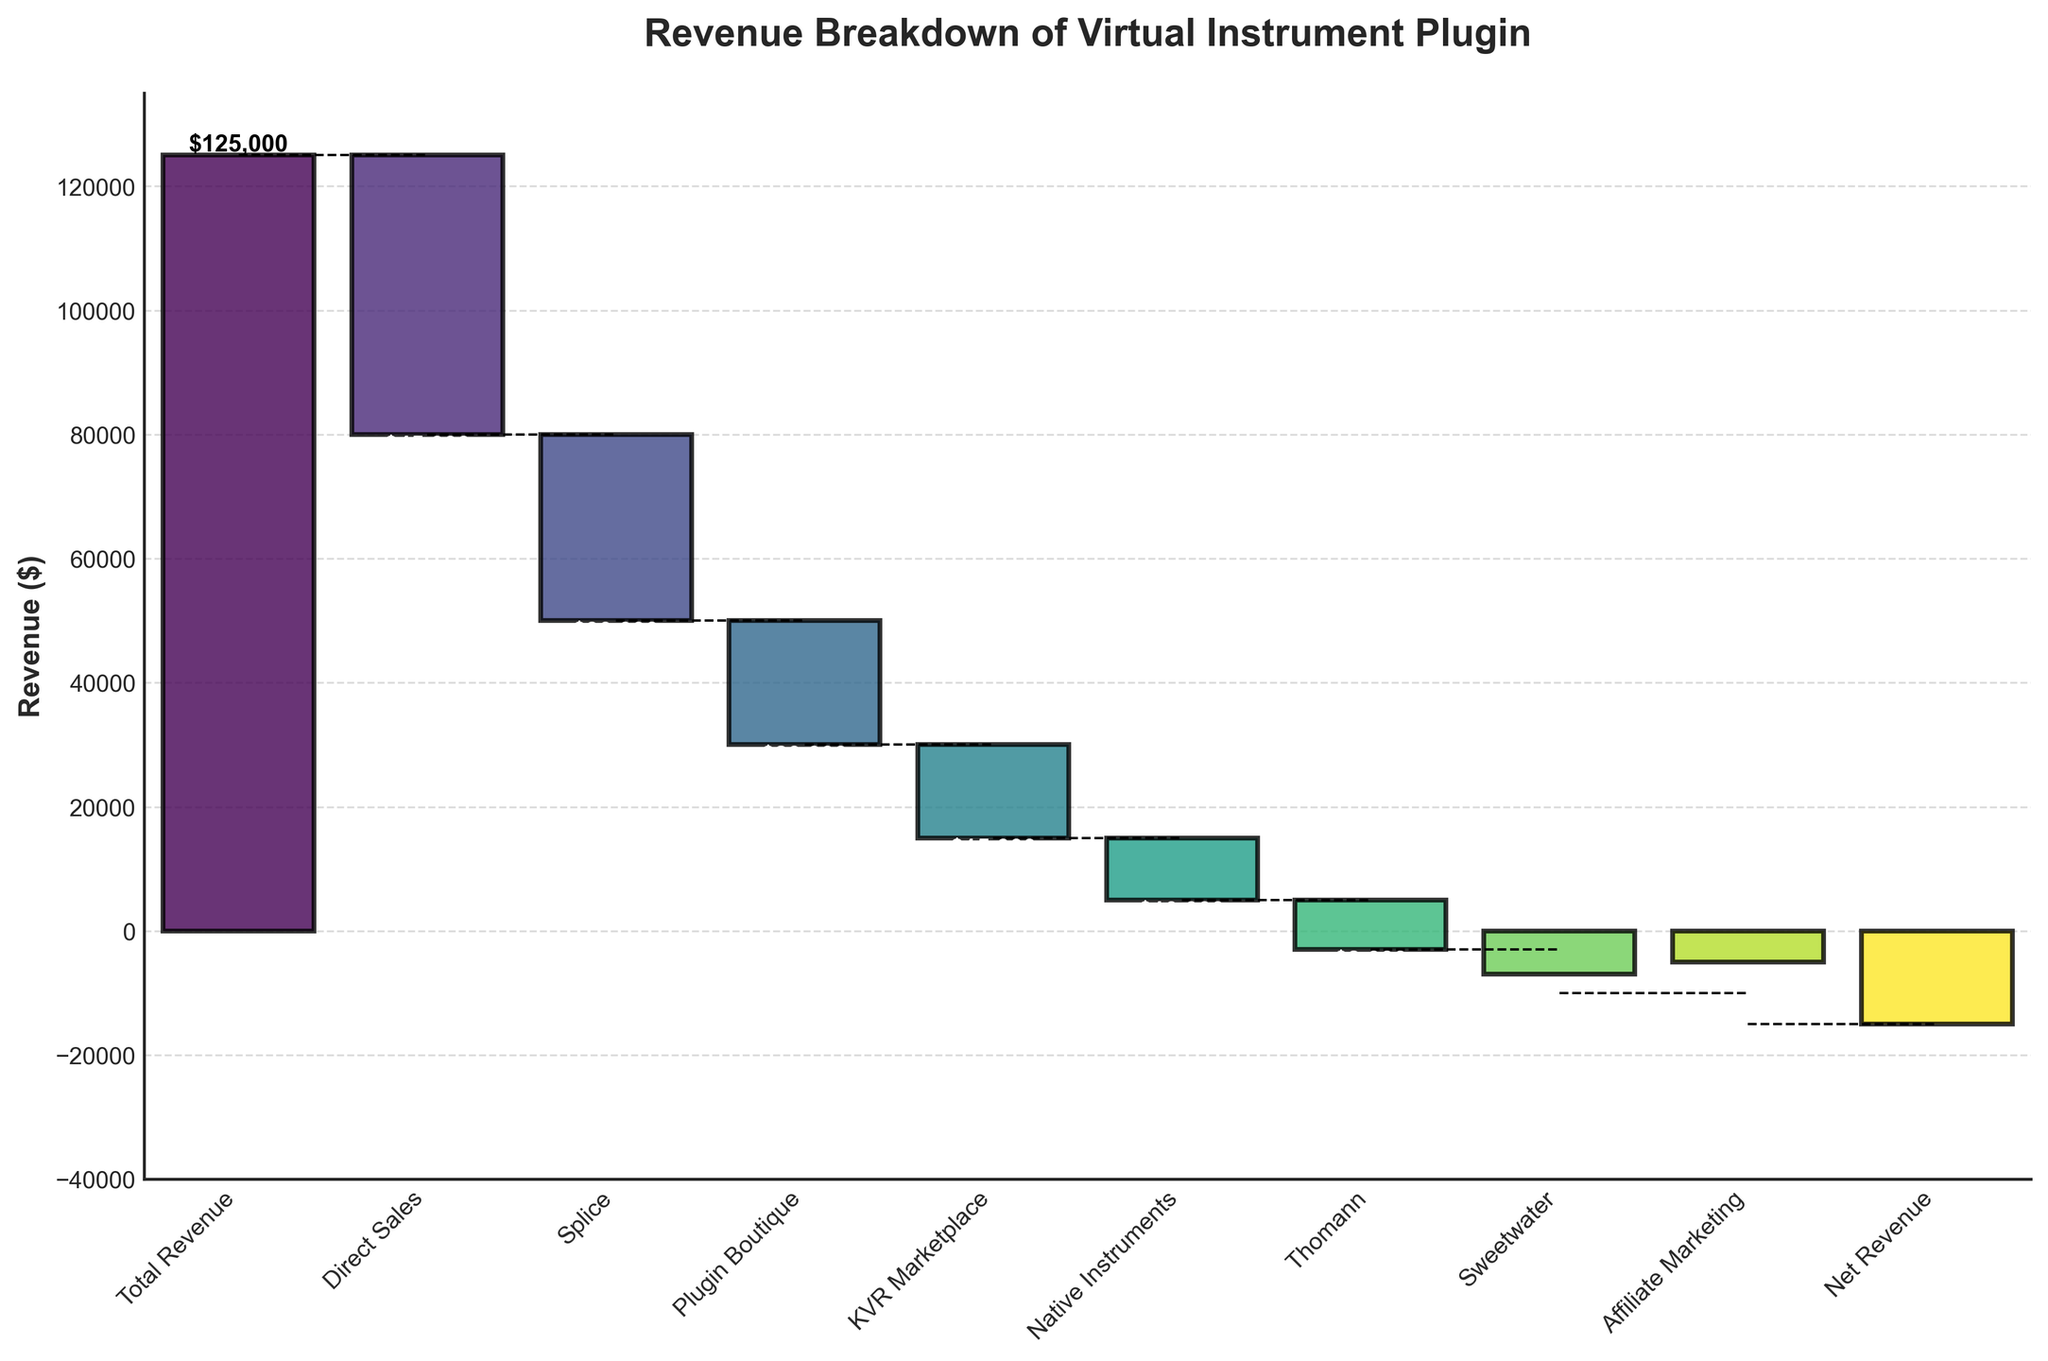What's the title of the chart? The title is typically located at the top of the chart and describes the content. Here, it reads 'Revenue Breakdown of Virtual Instrument Plugin'.
Answer: 'Revenue Breakdown of Virtual Instrument Plugin' What value does the 'Direct Sales' category contribute to the total revenue? By checking the label for 'Direct Sales' on the x-axis and finding its bar, we see the value is indicated near the bar, and it's labeled with the text '$45,000'. So the value contributed is -$45,000.
Answer: -$45,000 What is the total net revenue after all the deductions? The net revenue is usually the last bar in a waterfall chart indicating the final value after all additions and subtractions. Here, it is indicated as '-$15,000'.
Answer: -$15,000 Which category has the smallest impact on the revenue? To find the smallest impact, we look for the shortest bar either in the positive or negative direction. Here, 'Sweetwater' with -$7,000 has the smallest bar.
Answer: 'Sweetwater' How much more does 'Direct Sales' impact the revenue compared to 'Native Instruments'? The impact of 'Direct Sales' is -$45,000 while the impact of 'Native Instruments' is -$10,000. The difference is calculated as 45000 - 10000 = $35,000.
Answer: $35,000 Between 'Splice' and 'Thomann', which one had a larger negative impact on revenue and by how much? 'Splice' has an impact of -$30,000 and 'Thomann' has an impact of -$8,000. The difference is 30000 - 8000 = $22,000.
Answer: 'Splice' by $22,000 What would the revenue be if the 'Affiliate Marketing' impact was ignored? 'Affiliate Marketing' has an impact of -$5,000. Ignoring this, the net revenue would be -$15,000 + $5,000 = -$10,000.
Answer: -$10,000 What are the cumulative values after 'Plugin Boutique' and 'KVR Marketplace'? After 'Plugin Boutique', the cumulative is 100000 (since 125000 - 45000 = 80000 and then 80000 - 30000 = 50000) and after 'KVR Marketplace', the cumulative is 35000 (50000 - 15000).
Answer: 50000, 35000 